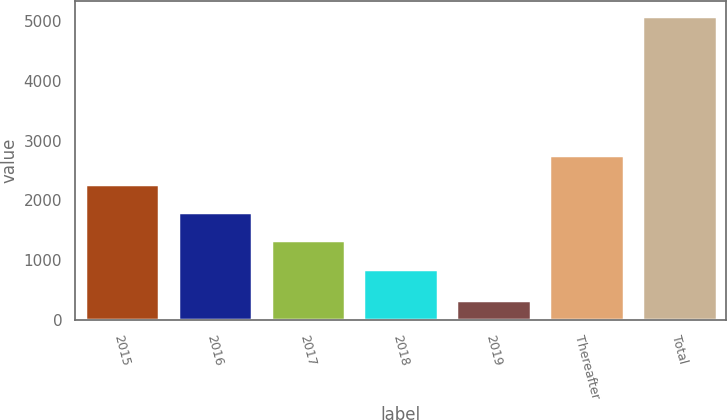Convert chart to OTSL. <chart><loc_0><loc_0><loc_500><loc_500><bar_chart><fcel>2015<fcel>2016<fcel>2017<fcel>2018<fcel>2019<fcel>Thereafter<fcel>Total<nl><fcel>2281<fcel>1806<fcel>1331<fcel>856<fcel>334<fcel>2756<fcel>5084<nl></chart> 